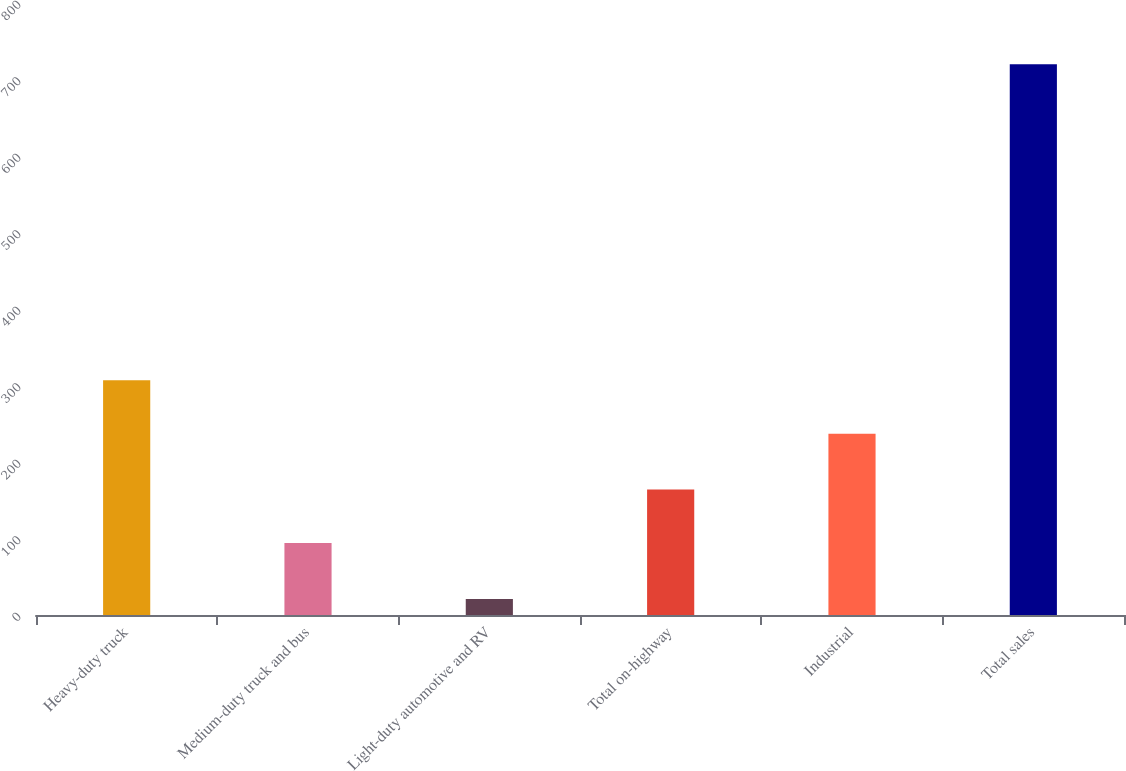Convert chart. <chart><loc_0><loc_0><loc_500><loc_500><bar_chart><fcel>Heavy-duty truck<fcel>Medium-duty truck and bus<fcel>Light-duty automotive and RV<fcel>Total on-highway<fcel>Industrial<fcel>Total sales<nl><fcel>306.9<fcel>94<fcel>21<fcel>163.9<fcel>237<fcel>720<nl></chart> 